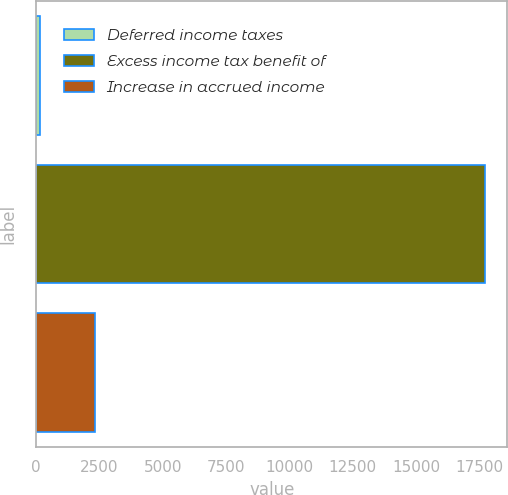<chart> <loc_0><loc_0><loc_500><loc_500><bar_chart><fcel>Deferred income taxes<fcel>Excess income tax benefit of<fcel>Increase in accrued income<nl><fcel>165<fcel>17718<fcel>2319<nl></chart> 